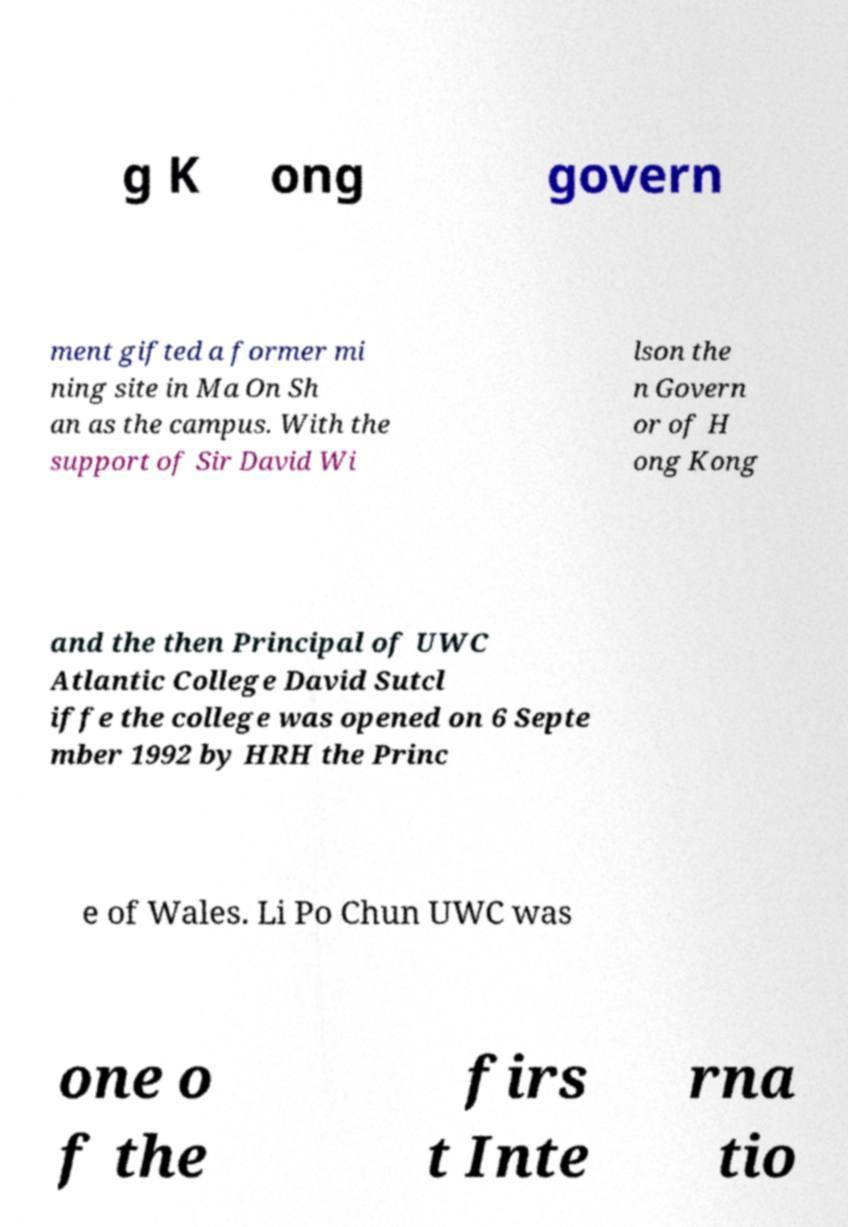Can you read and provide the text displayed in the image?This photo seems to have some interesting text. Can you extract and type it out for me? g K ong govern ment gifted a former mi ning site in Ma On Sh an as the campus. With the support of Sir David Wi lson the n Govern or of H ong Kong and the then Principal of UWC Atlantic College David Sutcl iffe the college was opened on 6 Septe mber 1992 by HRH the Princ e of Wales. Li Po Chun UWC was one o f the firs t Inte rna tio 